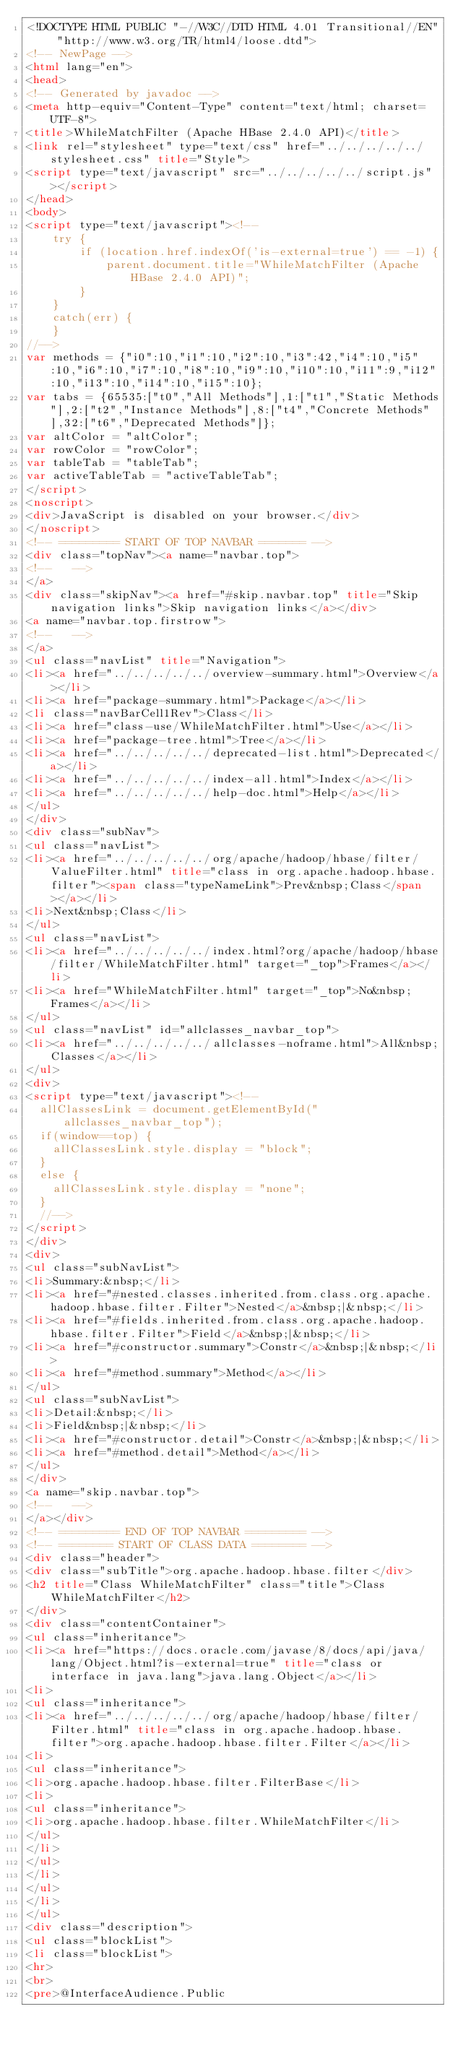<code> <loc_0><loc_0><loc_500><loc_500><_HTML_><!DOCTYPE HTML PUBLIC "-//W3C//DTD HTML 4.01 Transitional//EN" "http://www.w3.org/TR/html4/loose.dtd">
<!-- NewPage -->
<html lang="en">
<head>
<!-- Generated by javadoc -->
<meta http-equiv="Content-Type" content="text/html; charset=UTF-8">
<title>WhileMatchFilter (Apache HBase 2.4.0 API)</title>
<link rel="stylesheet" type="text/css" href="../../../../../stylesheet.css" title="Style">
<script type="text/javascript" src="../../../../../script.js"></script>
</head>
<body>
<script type="text/javascript"><!--
    try {
        if (location.href.indexOf('is-external=true') == -1) {
            parent.document.title="WhileMatchFilter (Apache HBase 2.4.0 API)";
        }
    }
    catch(err) {
    }
//-->
var methods = {"i0":10,"i1":10,"i2":10,"i3":42,"i4":10,"i5":10,"i6":10,"i7":10,"i8":10,"i9":10,"i10":10,"i11":9,"i12":10,"i13":10,"i14":10,"i15":10};
var tabs = {65535:["t0","All Methods"],1:["t1","Static Methods"],2:["t2","Instance Methods"],8:["t4","Concrete Methods"],32:["t6","Deprecated Methods"]};
var altColor = "altColor";
var rowColor = "rowColor";
var tableTab = "tableTab";
var activeTableTab = "activeTableTab";
</script>
<noscript>
<div>JavaScript is disabled on your browser.</div>
</noscript>
<!-- ========= START OF TOP NAVBAR ======= -->
<div class="topNav"><a name="navbar.top">
<!--   -->
</a>
<div class="skipNav"><a href="#skip.navbar.top" title="Skip navigation links">Skip navigation links</a></div>
<a name="navbar.top.firstrow">
<!--   -->
</a>
<ul class="navList" title="Navigation">
<li><a href="../../../../../overview-summary.html">Overview</a></li>
<li><a href="package-summary.html">Package</a></li>
<li class="navBarCell1Rev">Class</li>
<li><a href="class-use/WhileMatchFilter.html">Use</a></li>
<li><a href="package-tree.html">Tree</a></li>
<li><a href="../../../../../deprecated-list.html">Deprecated</a></li>
<li><a href="../../../../../index-all.html">Index</a></li>
<li><a href="../../../../../help-doc.html">Help</a></li>
</ul>
</div>
<div class="subNav">
<ul class="navList">
<li><a href="../../../../../org/apache/hadoop/hbase/filter/ValueFilter.html" title="class in org.apache.hadoop.hbase.filter"><span class="typeNameLink">Prev&nbsp;Class</span></a></li>
<li>Next&nbsp;Class</li>
</ul>
<ul class="navList">
<li><a href="../../../../../index.html?org/apache/hadoop/hbase/filter/WhileMatchFilter.html" target="_top">Frames</a></li>
<li><a href="WhileMatchFilter.html" target="_top">No&nbsp;Frames</a></li>
</ul>
<ul class="navList" id="allclasses_navbar_top">
<li><a href="../../../../../allclasses-noframe.html">All&nbsp;Classes</a></li>
</ul>
<div>
<script type="text/javascript"><!--
  allClassesLink = document.getElementById("allclasses_navbar_top");
  if(window==top) {
    allClassesLink.style.display = "block";
  }
  else {
    allClassesLink.style.display = "none";
  }
  //-->
</script>
</div>
<div>
<ul class="subNavList">
<li>Summary:&nbsp;</li>
<li><a href="#nested.classes.inherited.from.class.org.apache.hadoop.hbase.filter.Filter">Nested</a>&nbsp;|&nbsp;</li>
<li><a href="#fields.inherited.from.class.org.apache.hadoop.hbase.filter.Filter">Field</a>&nbsp;|&nbsp;</li>
<li><a href="#constructor.summary">Constr</a>&nbsp;|&nbsp;</li>
<li><a href="#method.summary">Method</a></li>
</ul>
<ul class="subNavList">
<li>Detail:&nbsp;</li>
<li>Field&nbsp;|&nbsp;</li>
<li><a href="#constructor.detail">Constr</a>&nbsp;|&nbsp;</li>
<li><a href="#method.detail">Method</a></li>
</ul>
</div>
<a name="skip.navbar.top">
<!--   -->
</a></div>
<!-- ========= END OF TOP NAVBAR ========= -->
<!-- ======== START OF CLASS DATA ======== -->
<div class="header">
<div class="subTitle">org.apache.hadoop.hbase.filter</div>
<h2 title="Class WhileMatchFilter" class="title">Class WhileMatchFilter</h2>
</div>
<div class="contentContainer">
<ul class="inheritance">
<li><a href="https://docs.oracle.com/javase/8/docs/api/java/lang/Object.html?is-external=true" title="class or interface in java.lang">java.lang.Object</a></li>
<li>
<ul class="inheritance">
<li><a href="../../../../../org/apache/hadoop/hbase/filter/Filter.html" title="class in org.apache.hadoop.hbase.filter">org.apache.hadoop.hbase.filter.Filter</a></li>
<li>
<ul class="inheritance">
<li>org.apache.hadoop.hbase.filter.FilterBase</li>
<li>
<ul class="inheritance">
<li>org.apache.hadoop.hbase.filter.WhileMatchFilter</li>
</ul>
</li>
</ul>
</li>
</ul>
</li>
</ul>
<div class="description">
<ul class="blockList">
<li class="blockList">
<hr>
<br>
<pre>@InterfaceAudience.Public</code> 